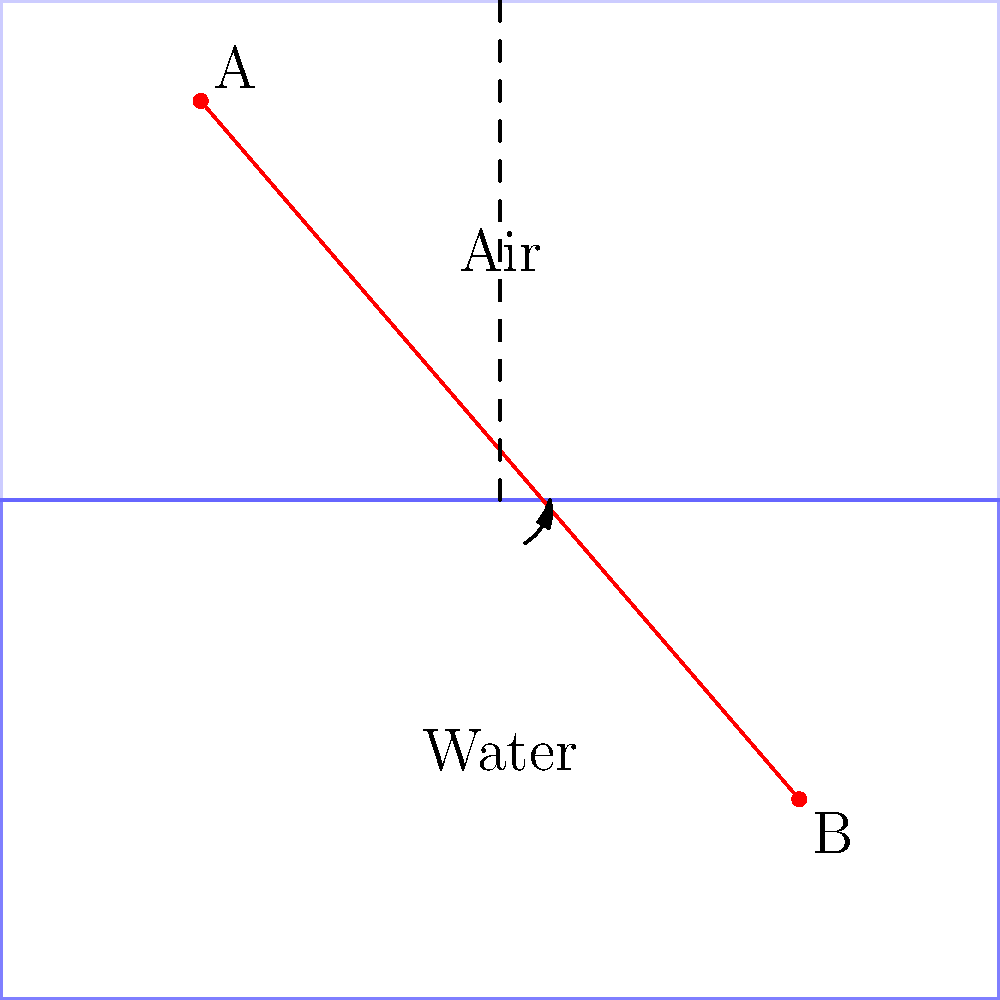In the diagram above, a light ray travels from point A in air to point B in water. Given that the refractive index of air is 1.00 and the refractive index of water is 1.33, calculate the angle of refraction in the water. Assume the angle of incidence in air is 60°. To solve this problem, we'll use Snell's Law, which describes the relationship between the angles of incidence and refraction for light passing through different media:

$$n_1 \sin(\theta_1) = n_2 \sin(\theta_2)$$

Where:
- $n_1$ is the refractive index of the first medium (air)
- $n_2$ is the refractive index of the second medium (water)
- $\theta_1$ is the angle of incidence in air
- $\theta_2$ is the angle of refraction in water

Given:
- $n_1 = 1.00$ (air)
- $n_2 = 1.33$ (water)
- $\theta_1 = 60°$

Step 1: Substitute the known values into Snell's Law:
$$(1.00) \sin(60°) = (1.33) \sin(\theta_2)$$

Step 2: Simplify the left side of the equation:
$$\sin(60°) = 1.33 \sin(\theta_2)$$
$$0.866 = 1.33 \sin(\theta_2)$$

Step 3: Solve for $\sin(\theta_2)$:
$$\sin(\theta_2) = \frac{0.866}{1.33} = 0.651$$

Step 4: Take the inverse sine (arcsin) of both sides to find $\theta_2$:
$$\theta_2 = \arcsin(0.651)$$
$$\theta_2 \approx 40.6°$$

Therefore, the angle of refraction in water is approximately 40.6°.
Answer: 40.6° 